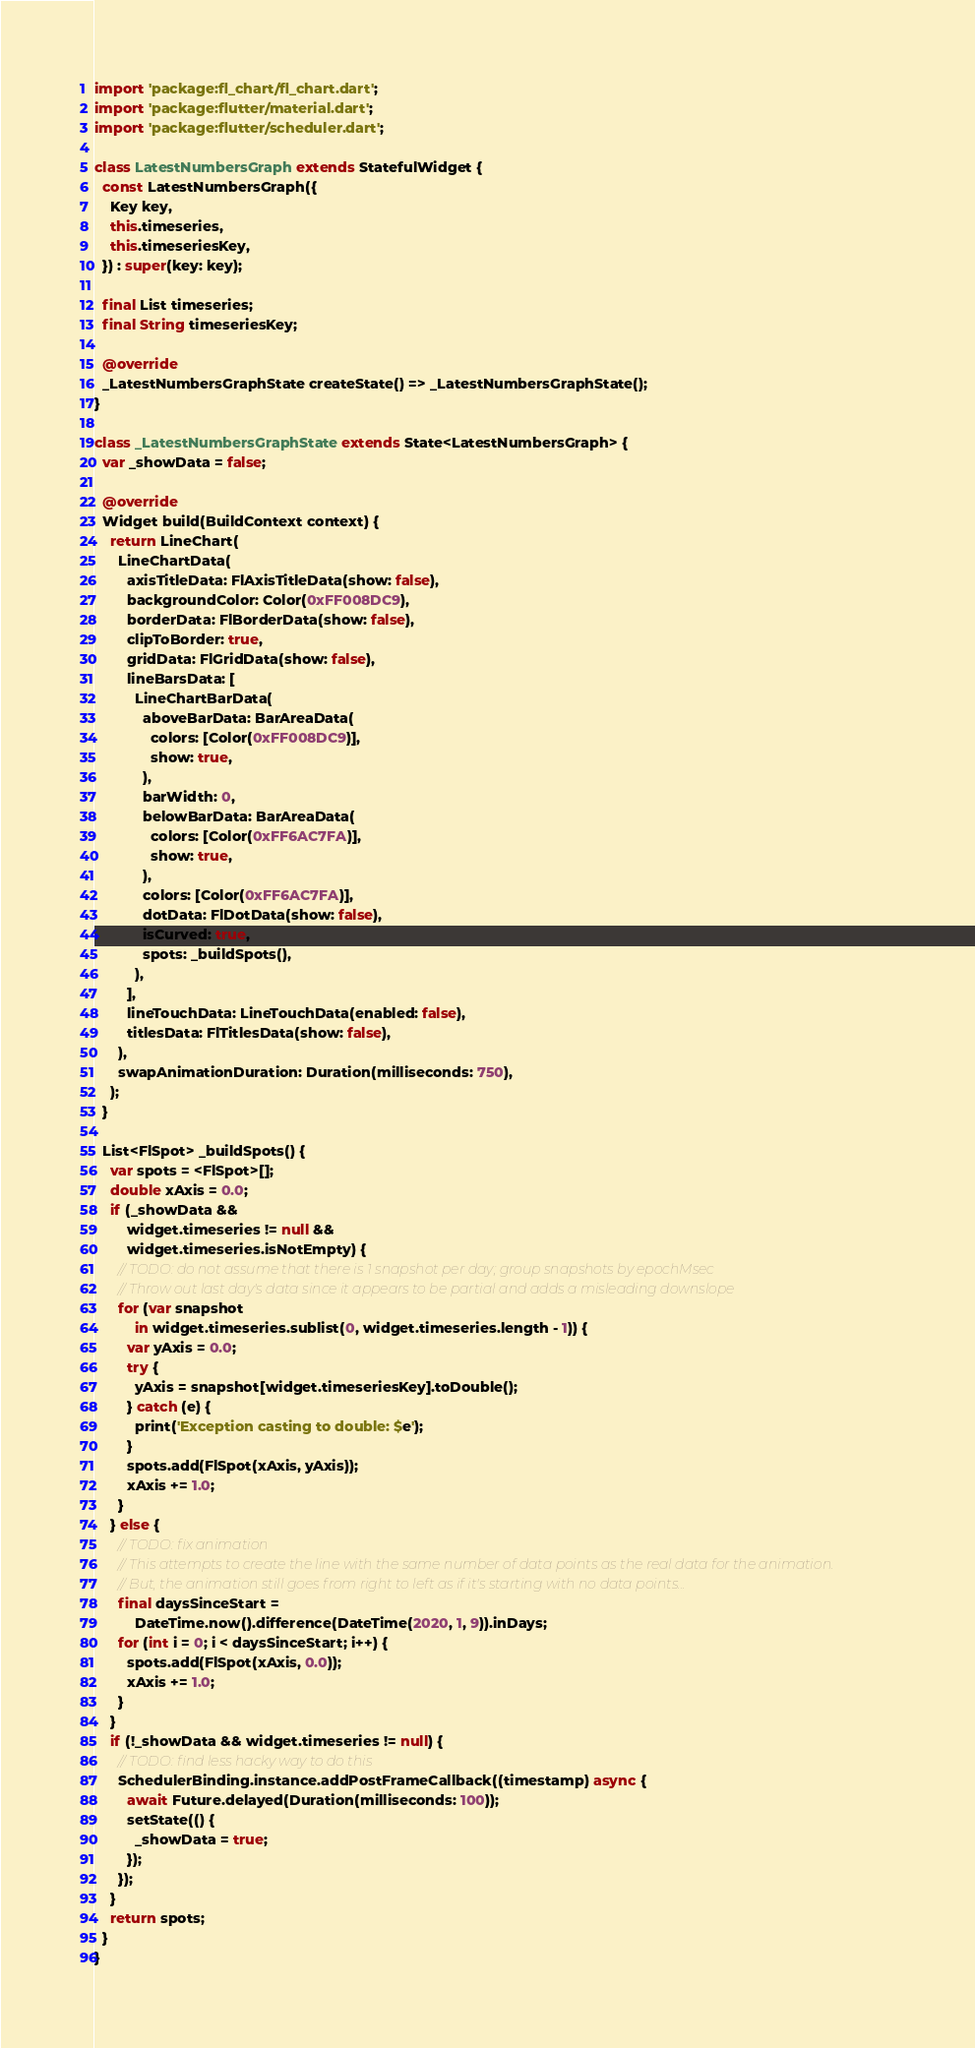Convert code to text. <code><loc_0><loc_0><loc_500><loc_500><_Dart_>import 'package:fl_chart/fl_chart.dart';
import 'package:flutter/material.dart';
import 'package:flutter/scheduler.dart';

class LatestNumbersGraph extends StatefulWidget {
  const LatestNumbersGraph({
    Key key,
    this.timeseries,
    this.timeseriesKey,
  }) : super(key: key);

  final List timeseries;
  final String timeseriesKey;

  @override
  _LatestNumbersGraphState createState() => _LatestNumbersGraphState();
}

class _LatestNumbersGraphState extends State<LatestNumbersGraph> {
  var _showData = false;

  @override
  Widget build(BuildContext context) {
    return LineChart(
      LineChartData(
        axisTitleData: FlAxisTitleData(show: false),
        backgroundColor: Color(0xFF008DC9),
        borderData: FlBorderData(show: false),
        clipToBorder: true,
        gridData: FlGridData(show: false),
        lineBarsData: [
          LineChartBarData(
            aboveBarData: BarAreaData(
              colors: [Color(0xFF008DC9)],
              show: true,
            ),
            barWidth: 0,
            belowBarData: BarAreaData(
              colors: [Color(0xFF6AC7FA)],
              show: true,
            ),
            colors: [Color(0xFF6AC7FA)],
            dotData: FlDotData(show: false),
            isCurved: true,
            spots: _buildSpots(),
          ),
        ],
        lineTouchData: LineTouchData(enabled: false),
        titlesData: FlTitlesData(show: false),
      ),
      swapAnimationDuration: Duration(milliseconds: 750),
    );
  }

  List<FlSpot> _buildSpots() {
    var spots = <FlSpot>[];
    double xAxis = 0.0;
    if (_showData &&
        widget.timeseries != null &&
        widget.timeseries.isNotEmpty) {
      // TODO: do not assume that there is 1 snapshot per day; group snapshots by epochMsec
      // Throw out last day's data since it appears to be partial and adds a misleading downslope
      for (var snapshot
          in widget.timeseries.sublist(0, widget.timeseries.length - 1)) {
        var yAxis = 0.0;
        try {
          yAxis = snapshot[widget.timeseriesKey].toDouble();
        } catch (e) {
          print('Exception casting to double: $e');
        }
        spots.add(FlSpot(xAxis, yAxis));
        xAxis += 1.0;
      }
    } else {
      // TODO: fix animation
      // This attempts to create the line with the same number of data points as the real data for the animation.
      // But, the animation still goes from right to left as if it's starting with no data points...
      final daysSinceStart =
          DateTime.now().difference(DateTime(2020, 1, 9)).inDays;
      for (int i = 0; i < daysSinceStart; i++) {
        spots.add(FlSpot(xAxis, 0.0));
        xAxis += 1.0;
      }
    }
    if (!_showData && widget.timeseries != null) {
      // TODO: find less hacky way to do this
      SchedulerBinding.instance.addPostFrameCallback((timestamp) async {
        await Future.delayed(Duration(milliseconds: 100));
        setState(() {
          _showData = true;
        });
      });
    }
    return spots;
  }
}
</code> 